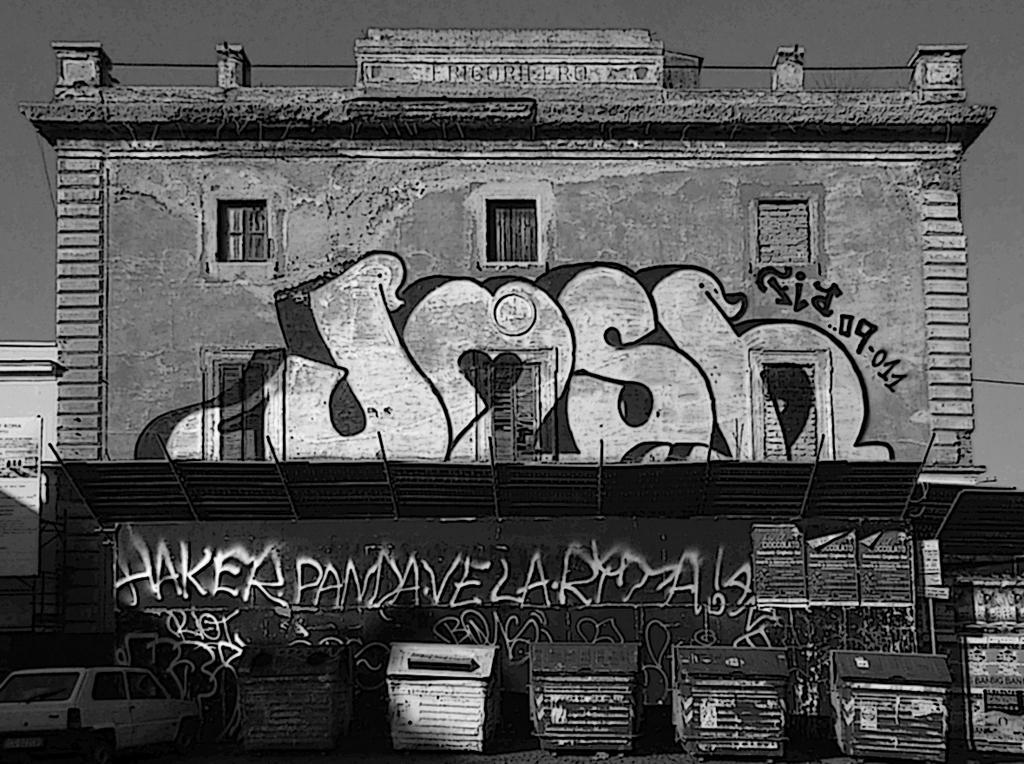What type of structure is visible in the image? There is a building in the image. Where is the car located in the image? The car is at the left bottom of the image. What objects can be seen at the bottom of the image? There are dustbins at the bottom of the image. How is the image presented in terms of color? The image is black and white. What kind of artwork is present on the building in the image? There is graffiti on the wall in the image. Can you tell me how many icicles are hanging from the building in the image? There are no icicles present in the image, as it is a black and white image and icicles would typically be associated with cold weather and snow, which are not depicted. 